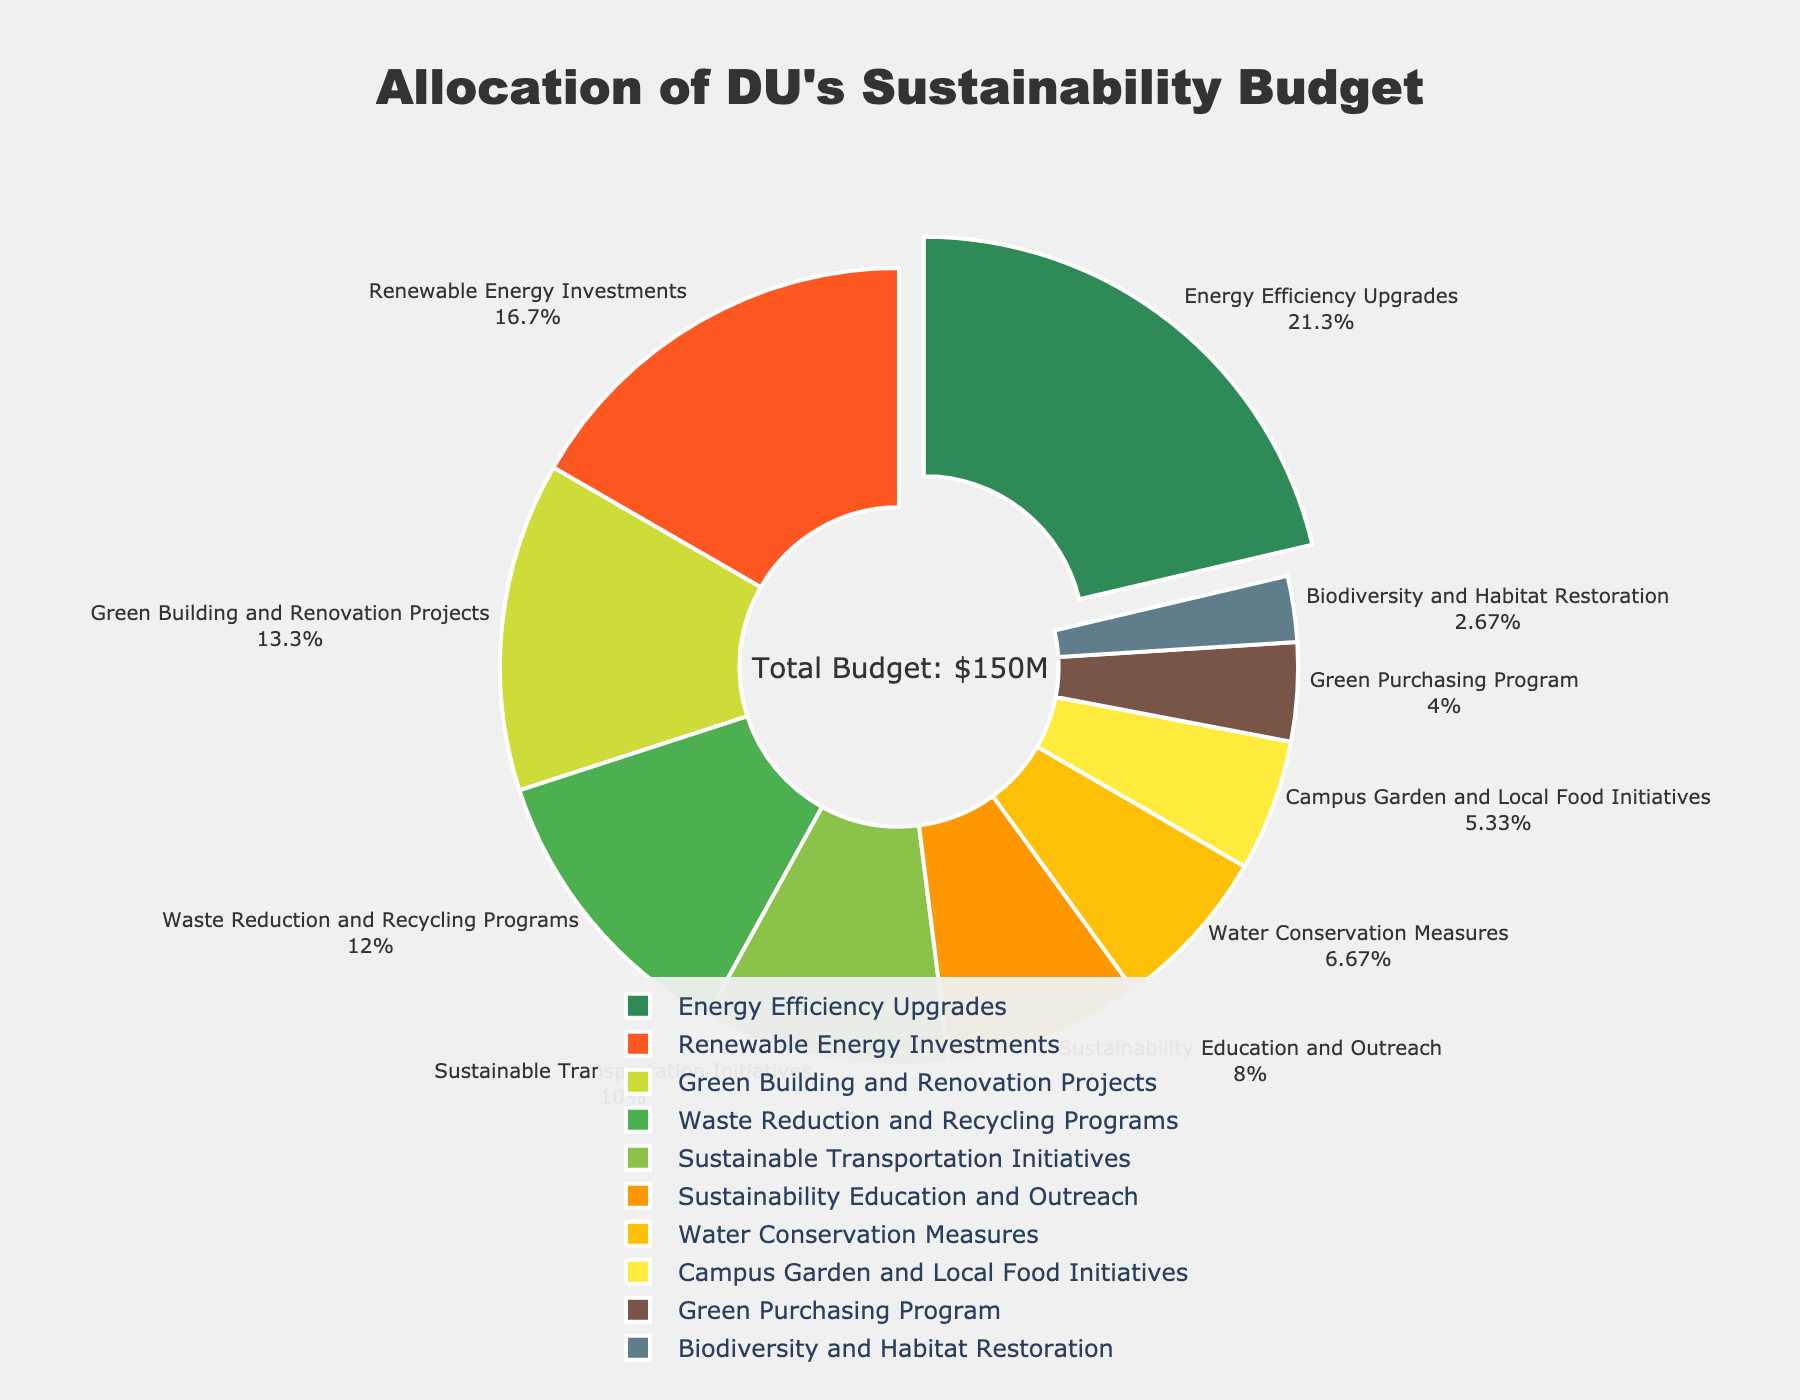Which initiative received the largest portion of the budget? The figure highlights the Energy Efficiency Upgrades section, which is slightly pulled out, indicating it receives the highest budget allocation.
Answer: Energy Efficiency Upgrades What is the total budget allocated to Renewable Energy Investments and Green Building and Renovation Projects combined? Renewable Energy Investments is allocated 25, and Green Building and Renovation Projects is allocated 20. Summing these amounts gives 25 + 20 = 45.
Answer: 45 Compare the budget allocations for Waste Reduction and Recycling Programs and Sustainable Transportation Initiatives. Which one has a higher budget? Waste Reduction and Recycling Programs is allocated 18, while Sustainable Transportation Initiatives is allocated 15. So, Waste Reduction and Recycling Programs has a higher budget.
Answer: Waste Reduction and Recycling Programs What percentage of the total budget is allocated to the Green Purchasing Program? According to the pie chart, the Green Purchasing Program is allocated 6 out of the total budget, which is 32 + 18 + 15 + 20 + 8 + 10 + 12 + 25 + 6 + 4 = 150. The percentage is (6/150) * 100 = 4%.
Answer: 4% Are Biodiversity and Habitat Restoration and Campus Garden and Local Food Initiatives allocated the same budget? The chart shows Biodiversity and Habitat Restoration is allocated 4, and Campus Garden and Local Food Initiatives is allocated 8. They are not the same.
Answer: No Which initiatives have less than 10% of the budget allocation each? To find this, we need to identify the initiatives with less than 15 (which is 10% of 150). These are Campus Garden and Local Food Initiatives (8), Green Purchasing Program (6), and Biodiversity and Habitat Restoration (4).
Answer: Campus Garden and Local Food Initiatives, Green Purchasing Program, Biodiversity and Habitat Restoration How much more budget is allocated to Sustainability Education and Outreach compared to the Green Purchasing Program? Sustainability Education and Outreach is allocated 12, and Green Purchasing Program is allocated 6. The difference is 12 - 6 = 6.
Answer: 6 Which initiative has the second-largest budget allocation, and what percentage of the total budget does it represent? Renewable Energy Investments has the second-largest allocation at 25. The total budget is 150. The percentage is (25/150) * 100 = 16.67%.
Answer: Renewable Energy Investments, 16.67% Calculate the mean budget allocation across all initiatives. The total budget is 150, and there are 10 initiatives. The mean allocation is 150/10 = 15.
Answer: 15 